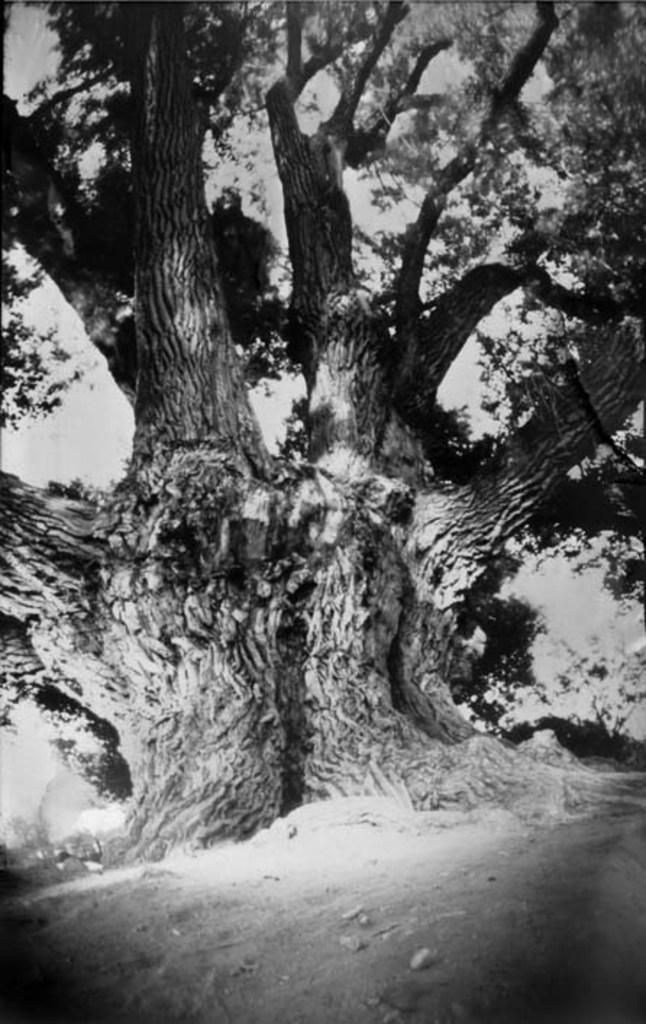What is the color scheme of the image? The image is black and white. What natural element can be seen in the image? There is a tree in the image. What specific features of the tree are visible? The tree has branches with leaves. What type of terrain is visible at the bottom of the image? There is land visible at the bottom of the image. What part of the natural environment is visible in the background of the image? The sky is visible in the background of the image. Where is the parent holding the meeting in the image? There is no parent or meeting present in the image; it features a tree with branches and leaves. How does the tree wash itself in the image? Trees do not wash themselves; they absorb water and nutrients through their roots. 